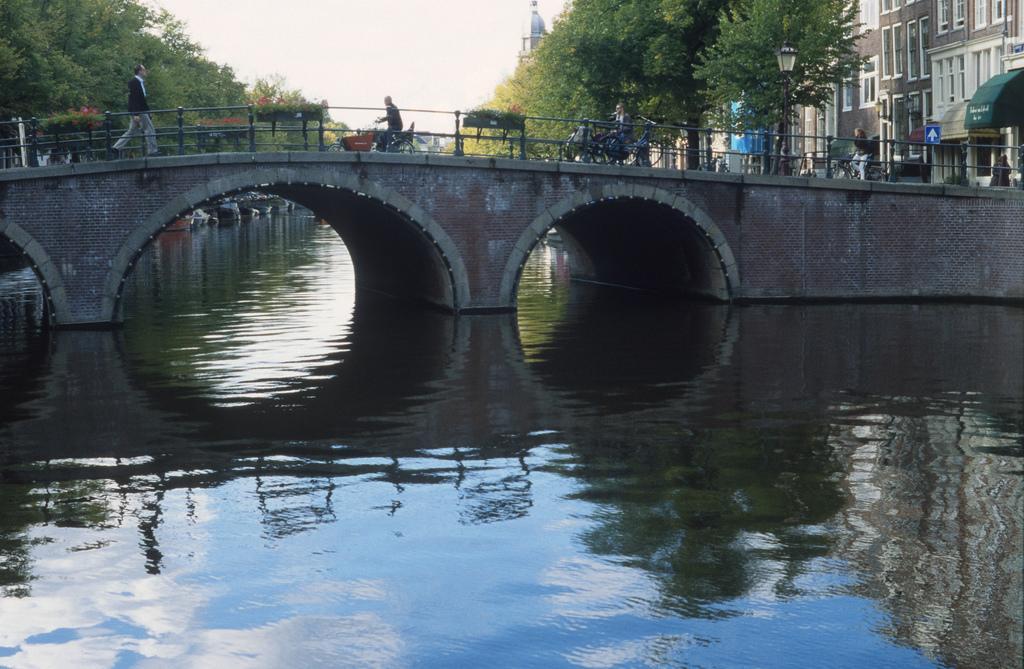How would you summarize this image in a sentence or two? In this image I can see a river, bridge,and people and bicycles on the bridge. Also there are trees buildings and the sky. 